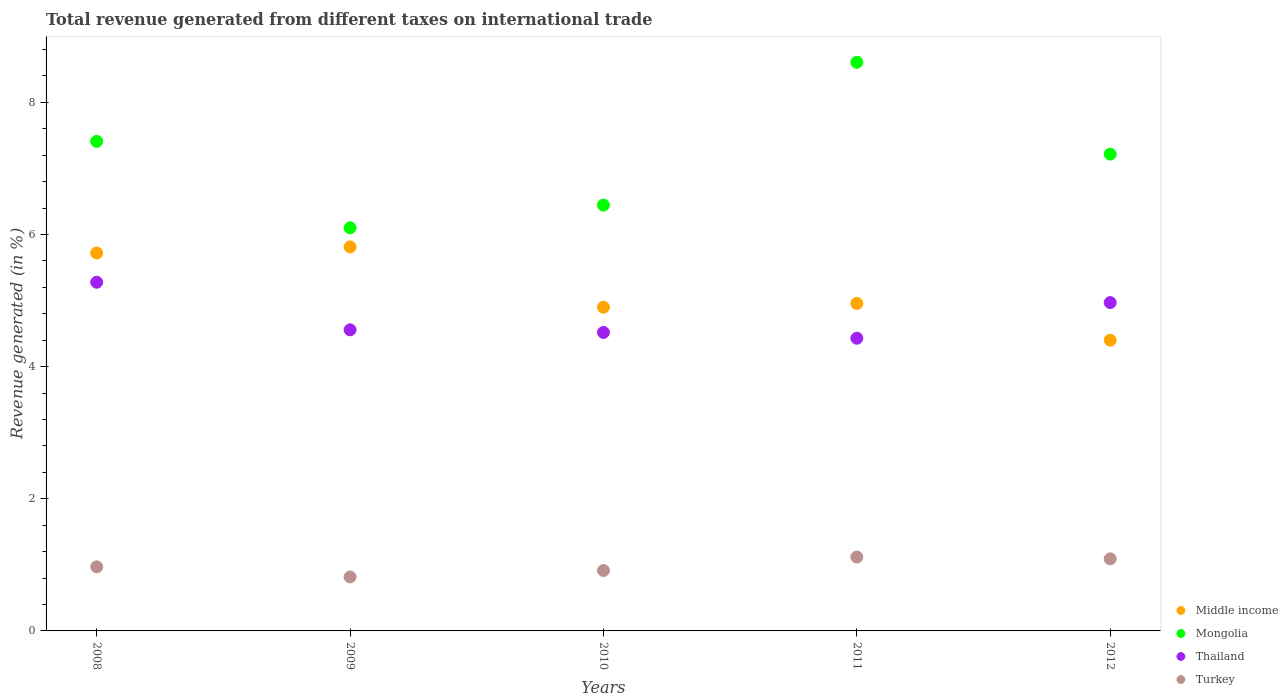What is the total revenue generated in Thailand in 2011?
Offer a terse response. 4.43. Across all years, what is the maximum total revenue generated in Mongolia?
Offer a very short reply. 8.61. Across all years, what is the minimum total revenue generated in Turkey?
Your answer should be compact. 0.82. What is the total total revenue generated in Turkey in the graph?
Give a very brief answer. 4.91. What is the difference between the total revenue generated in Turkey in 2008 and that in 2010?
Offer a very short reply. 0.06. What is the difference between the total revenue generated in Mongolia in 2011 and the total revenue generated in Thailand in 2010?
Offer a very short reply. 4.09. What is the average total revenue generated in Middle income per year?
Offer a very short reply. 5.16. In the year 2012, what is the difference between the total revenue generated in Turkey and total revenue generated in Thailand?
Make the answer very short. -3.88. In how many years, is the total revenue generated in Mongolia greater than 6.4 %?
Make the answer very short. 4. What is the ratio of the total revenue generated in Middle income in 2011 to that in 2012?
Offer a terse response. 1.13. Is the total revenue generated in Thailand in 2009 less than that in 2011?
Your answer should be very brief. No. What is the difference between the highest and the second highest total revenue generated in Thailand?
Make the answer very short. 0.31. What is the difference between the highest and the lowest total revenue generated in Mongolia?
Provide a succinct answer. 2.51. In how many years, is the total revenue generated in Middle income greater than the average total revenue generated in Middle income taken over all years?
Provide a succinct answer. 2. Is it the case that in every year, the sum of the total revenue generated in Thailand and total revenue generated in Turkey  is greater than the total revenue generated in Mongolia?
Keep it short and to the point. No. Does the total revenue generated in Thailand monotonically increase over the years?
Your response must be concise. No. Is the total revenue generated in Thailand strictly less than the total revenue generated in Middle income over the years?
Provide a succinct answer. No. How many dotlines are there?
Ensure brevity in your answer.  4. What is the difference between two consecutive major ticks on the Y-axis?
Make the answer very short. 2. Does the graph contain grids?
Your response must be concise. No. Where does the legend appear in the graph?
Offer a terse response. Bottom right. What is the title of the graph?
Keep it short and to the point. Total revenue generated from different taxes on international trade. Does "Latin America(developing only)" appear as one of the legend labels in the graph?
Offer a terse response. No. What is the label or title of the Y-axis?
Your response must be concise. Revenue generated (in %). What is the Revenue generated (in %) of Middle income in 2008?
Your answer should be very brief. 5.72. What is the Revenue generated (in %) in Mongolia in 2008?
Provide a succinct answer. 7.41. What is the Revenue generated (in %) of Thailand in 2008?
Your response must be concise. 5.28. What is the Revenue generated (in %) of Turkey in 2008?
Offer a very short reply. 0.97. What is the Revenue generated (in %) of Middle income in 2009?
Ensure brevity in your answer.  5.81. What is the Revenue generated (in %) in Mongolia in 2009?
Provide a succinct answer. 6.1. What is the Revenue generated (in %) in Thailand in 2009?
Offer a terse response. 4.56. What is the Revenue generated (in %) in Turkey in 2009?
Make the answer very short. 0.82. What is the Revenue generated (in %) in Middle income in 2010?
Make the answer very short. 4.9. What is the Revenue generated (in %) in Mongolia in 2010?
Offer a very short reply. 6.44. What is the Revenue generated (in %) in Thailand in 2010?
Offer a terse response. 4.52. What is the Revenue generated (in %) in Turkey in 2010?
Ensure brevity in your answer.  0.91. What is the Revenue generated (in %) in Middle income in 2011?
Your response must be concise. 4.96. What is the Revenue generated (in %) in Mongolia in 2011?
Give a very brief answer. 8.61. What is the Revenue generated (in %) in Thailand in 2011?
Your answer should be very brief. 4.43. What is the Revenue generated (in %) in Turkey in 2011?
Offer a very short reply. 1.12. What is the Revenue generated (in %) in Middle income in 2012?
Give a very brief answer. 4.4. What is the Revenue generated (in %) of Mongolia in 2012?
Provide a short and direct response. 7.22. What is the Revenue generated (in %) in Thailand in 2012?
Offer a very short reply. 4.97. What is the Revenue generated (in %) of Turkey in 2012?
Offer a very short reply. 1.09. Across all years, what is the maximum Revenue generated (in %) in Middle income?
Provide a succinct answer. 5.81. Across all years, what is the maximum Revenue generated (in %) of Mongolia?
Your answer should be very brief. 8.61. Across all years, what is the maximum Revenue generated (in %) in Thailand?
Your answer should be very brief. 5.28. Across all years, what is the maximum Revenue generated (in %) of Turkey?
Keep it short and to the point. 1.12. Across all years, what is the minimum Revenue generated (in %) in Middle income?
Keep it short and to the point. 4.4. Across all years, what is the minimum Revenue generated (in %) in Mongolia?
Provide a short and direct response. 6.1. Across all years, what is the minimum Revenue generated (in %) of Thailand?
Your answer should be very brief. 4.43. Across all years, what is the minimum Revenue generated (in %) of Turkey?
Make the answer very short. 0.82. What is the total Revenue generated (in %) in Middle income in the graph?
Ensure brevity in your answer.  25.79. What is the total Revenue generated (in %) in Mongolia in the graph?
Provide a short and direct response. 35.77. What is the total Revenue generated (in %) in Thailand in the graph?
Provide a short and direct response. 23.75. What is the total Revenue generated (in %) of Turkey in the graph?
Ensure brevity in your answer.  4.91. What is the difference between the Revenue generated (in %) of Middle income in 2008 and that in 2009?
Provide a succinct answer. -0.09. What is the difference between the Revenue generated (in %) in Mongolia in 2008 and that in 2009?
Your response must be concise. 1.31. What is the difference between the Revenue generated (in %) of Thailand in 2008 and that in 2009?
Offer a terse response. 0.72. What is the difference between the Revenue generated (in %) of Turkey in 2008 and that in 2009?
Provide a short and direct response. 0.15. What is the difference between the Revenue generated (in %) in Middle income in 2008 and that in 2010?
Ensure brevity in your answer.  0.82. What is the difference between the Revenue generated (in %) in Mongolia in 2008 and that in 2010?
Keep it short and to the point. 0.96. What is the difference between the Revenue generated (in %) in Thailand in 2008 and that in 2010?
Your answer should be very brief. 0.76. What is the difference between the Revenue generated (in %) of Turkey in 2008 and that in 2010?
Provide a short and direct response. 0.06. What is the difference between the Revenue generated (in %) of Middle income in 2008 and that in 2011?
Offer a terse response. 0.76. What is the difference between the Revenue generated (in %) in Mongolia in 2008 and that in 2011?
Ensure brevity in your answer.  -1.2. What is the difference between the Revenue generated (in %) of Thailand in 2008 and that in 2011?
Offer a very short reply. 0.85. What is the difference between the Revenue generated (in %) of Turkey in 2008 and that in 2011?
Keep it short and to the point. -0.15. What is the difference between the Revenue generated (in %) of Middle income in 2008 and that in 2012?
Give a very brief answer. 1.32. What is the difference between the Revenue generated (in %) of Mongolia in 2008 and that in 2012?
Offer a terse response. 0.19. What is the difference between the Revenue generated (in %) of Thailand in 2008 and that in 2012?
Provide a succinct answer. 0.31. What is the difference between the Revenue generated (in %) of Turkey in 2008 and that in 2012?
Give a very brief answer. -0.12. What is the difference between the Revenue generated (in %) of Middle income in 2009 and that in 2010?
Your answer should be compact. 0.91. What is the difference between the Revenue generated (in %) of Mongolia in 2009 and that in 2010?
Give a very brief answer. -0.34. What is the difference between the Revenue generated (in %) of Turkey in 2009 and that in 2010?
Your answer should be very brief. -0.1. What is the difference between the Revenue generated (in %) of Middle income in 2009 and that in 2011?
Ensure brevity in your answer.  0.85. What is the difference between the Revenue generated (in %) in Mongolia in 2009 and that in 2011?
Your answer should be very brief. -2.5. What is the difference between the Revenue generated (in %) of Thailand in 2009 and that in 2011?
Offer a very short reply. 0.13. What is the difference between the Revenue generated (in %) in Turkey in 2009 and that in 2011?
Offer a terse response. -0.3. What is the difference between the Revenue generated (in %) of Middle income in 2009 and that in 2012?
Give a very brief answer. 1.41. What is the difference between the Revenue generated (in %) in Mongolia in 2009 and that in 2012?
Provide a short and direct response. -1.12. What is the difference between the Revenue generated (in %) of Thailand in 2009 and that in 2012?
Your answer should be compact. -0.41. What is the difference between the Revenue generated (in %) in Turkey in 2009 and that in 2012?
Ensure brevity in your answer.  -0.27. What is the difference between the Revenue generated (in %) of Middle income in 2010 and that in 2011?
Provide a succinct answer. -0.06. What is the difference between the Revenue generated (in %) in Mongolia in 2010 and that in 2011?
Keep it short and to the point. -2.16. What is the difference between the Revenue generated (in %) in Thailand in 2010 and that in 2011?
Keep it short and to the point. 0.09. What is the difference between the Revenue generated (in %) of Turkey in 2010 and that in 2011?
Offer a terse response. -0.2. What is the difference between the Revenue generated (in %) of Middle income in 2010 and that in 2012?
Keep it short and to the point. 0.5. What is the difference between the Revenue generated (in %) in Mongolia in 2010 and that in 2012?
Provide a short and direct response. -0.77. What is the difference between the Revenue generated (in %) of Thailand in 2010 and that in 2012?
Your response must be concise. -0.45. What is the difference between the Revenue generated (in %) of Turkey in 2010 and that in 2012?
Give a very brief answer. -0.18. What is the difference between the Revenue generated (in %) in Middle income in 2011 and that in 2012?
Keep it short and to the point. 0.56. What is the difference between the Revenue generated (in %) of Mongolia in 2011 and that in 2012?
Give a very brief answer. 1.39. What is the difference between the Revenue generated (in %) of Thailand in 2011 and that in 2012?
Make the answer very short. -0.54. What is the difference between the Revenue generated (in %) in Turkey in 2011 and that in 2012?
Your answer should be compact. 0.03. What is the difference between the Revenue generated (in %) in Middle income in 2008 and the Revenue generated (in %) in Mongolia in 2009?
Your response must be concise. -0.38. What is the difference between the Revenue generated (in %) of Middle income in 2008 and the Revenue generated (in %) of Thailand in 2009?
Your answer should be very brief. 1.16. What is the difference between the Revenue generated (in %) of Middle income in 2008 and the Revenue generated (in %) of Turkey in 2009?
Provide a short and direct response. 4.9. What is the difference between the Revenue generated (in %) of Mongolia in 2008 and the Revenue generated (in %) of Thailand in 2009?
Offer a terse response. 2.85. What is the difference between the Revenue generated (in %) in Mongolia in 2008 and the Revenue generated (in %) in Turkey in 2009?
Provide a succinct answer. 6.59. What is the difference between the Revenue generated (in %) in Thailand in 2008 and the Revenue generated (in %) in Turkey in 2009?
Give a very brief answer. 4.46. What is the difference between the Revenue generated (in %) in Middle income in 2008 and the Revenue generated (in %) in Mongolia in 2010?
Give a very brief answer. -0.72. What is the difference between the Revenue generated (in %) in Middle income in 2008 and the Revenue generated (in %) in Thailand in 2010?
Your answer should be compact. 1.2. What is the difference between the Revenue generated (in %) of Middle income in 2008 and the Revenue generated (in %) of Turkey in 2010?
Your answer should be compact. 4.81. What is the difference between the Revenue generated (in %) of Mongolia in 2008 and the Revenue generated (in %) of Thailand in 2010?
Ensure brevity in your answer.  2.89. What is the difference between the Revenue generated (in %) in Mongolia in 2008 and the Revenue generated (in %) in Turkey in 2010?
Give a very brief answer. 6.49. What is the difference between the Revenue generated (in %) in Thailand in 2008 and the Revenue generated (in %) in Turkey in 2010?
Keep it short and to the point. 4.36. What is the difference between the Revenue generated (in %) of Middle income in 2008 and the Revenue generated (in %) of Mongolia in 2011?
Offer a very short reply. -2.89. What is the difference between the Revenue generated (in %) of Middle income in 2008 and the Revenue generated (in %) of Thailand in 2011?
Keep it short and to the point. 1.29. What is the difference between the Revenue generated (in %) in Middle income in 2008 and the Revenue generated (in %) in Turkey in 2011?
Your response must be concise. 4.6. What is the difference between the Revenue generated (in %) of Mongolia in 2008 and the Revenue generated (in %) of Thailand in 2011?
Provide a succinct answer. 2.98. What is the difference between the Revenue generated (in %) in Mongolia in 2008 and the Revenue generated (in %) in Turkey in 2011?
Your response must be concise. 6.29. What is the difference between the Revenue generated (in %) in Thailand in 2008 and the Revenue generated (in %) in Turkey in 2011?
Your response must be concise. 4.16. What is the difference between the Revenue generated (in %) in Middle income in 2008 and the Revenue generated (in %) in Mongolia in 2012?
Offer a terse response. -1.5. What is the difference between the Revenue generated (in %) in Middle income in 2008 and the Revenue generated (in %) in Thailand in 2012?
Give a very brief answer. 0.75. What is the difference between the Revenue generated (in %) of Middle income in 2008 and the Revenue generated (in %) of Turkey in 2012?
Your answer should be compact. 4.63. What is the difference between the Revenue generated (in %) of Mongolia in 2008 and the Revenue generated (in %) of Thailand in 2012?
Your response must be concise. 2.44. What is the difference between the Revenue generated (in %) of Mongolia in 2008 and the Revenue generated (in %) of Turkey in 2012?
Provide a succinct answer. 6.32. What is the difference between the Revenue generated (in %) of Thailand in 2008 and the Revenue generated (in %) of Turkey in 2012?
Your response must be concise. 4.19. What is the difference between the Revenue generated (in %) of Middle income in 2009 and the Revenue generated (in %) of Mongolia in 2010?
Your response must be concise. -0.63. What is the difference between the Revenue generated (in %) of Middle income in 2009 and the Revenue generated (in %) of Thailand in 2010?
Offer a very short reply. 1.29. What is the difference between the Revenue generated (in %) of Middle income in 2009 and the Revenue generated (in %) of Turkey in 2010?
Provide a short and direct response. 4.9. What is the difference between the Revenue generated (in %) in Mongolia in 2009 and the Revenue generated (in %) in Thailand in 2010?
Your response must be concise. 1.58. What is the difference between the Revenue generated (in %) in Mongolia in 2009 and the Revenue generated (in %) in Turkey in 2010?
Provide a short and direct response. 5.19. What is the difference between the Revenue generated (in %) of Thailand in 2009 and the Revenue generated (in %) of Turkey in 2010?
Provide a short and direct response. 3.64. What is the difference between the Revenue generated (in %) of Middle income in 2009 and the Revenue generated (in %) of Mongolia in 2011?
Provide a succinct answer. -2.79. What is the difference between the Revenue generated (in %) in Middle income in 2009 and the Revenue generated (in %) in Thailand in 2011?
Keep it short and to the point. 1.38. What is the difference between the Revenue generated (in %) of Middle income in 2009 and the Revenue generated (in %) of Turkey in 2011?
Provide a short and direct response. 4.69. What is the difference between the Revenue generated (in %) in Mongolia in 2009 and the Revenue generated (in %) in Thailand in 2011?
Give a very brief answer. 1.67. What is the difference between the Revenue generated (in %) of Mongolia in 2009 and the Revenue generated (in %) of Turkey in 2011?
Keep it short and to the point. 4.98. What is the difference between the Revenue generated (in %) in Thailand in 2009 and the Revenue generated (in %) in Turkey in 2011?
Make the answer very short. 3.44. What is the difference between the Revenue generated (in %) in Middle income in 2009 and the Revenue generated (in %) in Mongolia in 2012?
Offer a terse response. -1.4. What is the difference between the Revenue generated (in %) of Middle income in 2009 and the Revenue generated (in %) of Thailand in 2012?
Provide a succinct answer. 0.84. What is the difference between the Revenue generated (in %) of Middle income in 2009 and the Revenue generated (in %) of Turkey in 2012?
Offer a very short reply. 4.72. What is the difference between the Revenue generated (in %) of Mongolia in 2009 and the Revenue generated (in %) of Thailand in 2012?
Make the answer very short. 1.13. What is the difference between the Revenue generated (in %) in Mongolia in 2009 and the Revenue generated (in %) in Turkey in 2012?
Provide a succinct answer. 5.01. What is the difference between the Revenue generated (in %) in Thailand in 2009 and the Revenue generated (in %) in Turkey in 2012?
Provide a short and direct response. 3.47. What is the difference between the Revenue generated (in %) in Middle income in 2010 and the Revenue generated (in %) in Mongolia in 2011?
Your answer should be compact. -3.71. What is the difference between the Revenue generated (in %) in Middle income in 2010 and the Revenue generated (in %) in Thailand in 2011?
Your response must be concise. 0.47. What is the difference between the Revenue generated (in %) of Middle income in 2010 and the Revenue generated (in %) of Turkey in 2011?
Keep it short and to the point. 3.78. What is the difference between the Revenue generated (in %) in Mongolia in 2010 and the Revenue generated (in %) in Thailand in 2011?
Give a very brief answer. 2.01. What is the difference between the Revenue generated (in %) of Mongolia in 2010 and the Revenue generated (in %) of Turkey in 2011?
Your response must be concise. 5.33. What is the difference between the Revenue generated (in %) of Thailand in 2010 and the Revenue generated (in %) of Turkey in 2011?
Offer a very short reply. 3.4. What is the difference between the Revenue generated (in %) of Middle income in 2010 and the Revenue generated (in %) of Mongolia in 2012?
Your answer should be very brief. -2.32. What is the difference between the Revenue generated (in %) in Middle income in 2010 and the Revenue generated (in %) in Thailand in 2012?
Offer a terse response. -0.07. What is the difference between the Revenue generated (in %) of Middle income in 2010 and the Revenue generated (in %) of Turkey in 2012?
Your answer should be very brief. 3.81. What is the difference between the Revenue generated (in %) of Mongolia in 2010 and the Revenue generated (in %) of Thailand in 2012?
Your answer should be very brief. 1.47. What is the difference between the Revenue generated (in %) in Mongolia in 2010 and the Revenue generated (in %) in Turkey in 2012?
Ensure brevity in your answer.  5.35. What is the difference between the Revenue generated (in %) of Thailand in 2010 and the Revenue generated (in %) of Turkey in 2012?
Your response must be concise. 3.43. What is the difference between the Revenue generated (in %) in Middle income in 2011 and the Revenue generated (in %) in Mongolia in 2012?
Your answer should be very brief. -2.26. What is the difference between the Revenue generated (in %) of Middle income in 2011 and the Revenue generated (in %) of Thailand in 2012?
Provide a succinct answer. -0.01. What is the difference between the Revenue generated (in %) of Middle income in 2011 and the Revenue generated (in %) of Turkey in 2012?
Provide a succinct answer. 3.87. What is the difference between the Revenue generated (in %) in Mongolia in 2011 and the Revenue generated (in %) in Thailand in 2012?
Make the answer very short. 3.64. What is the difference between the Revenue generated (in %) of Mongolia in 2011 and the Revenue generated (in %) of Turkey in 2012?
Make the answer very short. 7.51. What is the difference between the Revenue generated (in %) in Thailand in 2011 and the Revenue generated (in %) in Turkey in 2012?
Your response must be concise. 3.34. What is the average Revenue generated (in %) in Middle income per year?
Your answer should be compact. 5.16. What is the average Revenue generated (in %) of Mongolia per year?
Provide a succinct answer. 7.15. What is the average Revenue generated (in %) of Thailand per year?
Provide a succinct answer. 4.75. What is the average Revenue generated (in %) in Turkey per year?
Provide a short and direct response. 0.98. In the year 2008, what is the difference between the Revenue generated (in %) of Middle income and Revenue generated (in %) of Mongolia?
Give a very brief answer. -1.69. In the year 2008, what is the difference between the Revenue generated (in %) in Middle income and Revenue generated (in %) in Thailand?
Give a very brief answer. 0.44. In the year 2008, what is the difference between the Revenue generated (in %) of Middle income and Revenue generated (in %) of Turkey?
Ensure brevity in your answer.  4.75. In the year 2008, what is the difference between the Revenue generated (in %) of Mongolia and Revenue generated (in %) of Thailand?
Offer a very short reply. 2.13. In the year 2008, what is the difference between the Revenue generated (in %) of Mongolia and Revenue generated (in %) of Turkey?
Ensure brevity in your answer.  6.44. In the year 2008, what is the difference between the Revenue generated (in %) of Thailand and Revenue generated (in %) of Turkey?
Keep it short and to the point. 4.31. In the year 2009, what is the difference between the Revenue generated (in %) in Middle income and Revenue generated (in %) in Mongolia?
Ensure brevity in your answer.  -0.29. In the year 2009, what is the difference between the Revenue generated (in %) in Middle income and Revenue generated (in %) in Thailand?
Provide a succinct answer. 1.25. In the year 2009, what is the difference between the Revenue generated (in %) in Middle income and Revenue generated (in %) in Turkey?
Give a very brief answer. 4.99. In the year 2009, what is the difference between the Revenue generated (in %) in Mongolia and Revenue generated (in %) in Thailand?
Provide a short and direct response. 1.54. In the year 2009, what is the difference between the Revenue generated (in %) in Mongolia and Revenue generated (in %) in Turkey?
Make the answer very short. 5.28. In the year 2009, what is the difference between the Revenue generated (in %) in Thailand and Revenue generated (in %) in Turkey?
Your answer should be compact. 3.74. In the year 2010, what is the difference between the Revenue generated (in %) of Middle income and Revenue generated (in %) of Mongolia?
Keep it short and to the point. -1.54. In the year 2010, what is the difference between the Revenue generated (in %) of Middle income and Revenue generated (in %) of Thailand?
Provide a succinct answer. 0.38. In the year 2010, what is the difference between the Revenue generated (in %) of Middle income and Revenue generated (in %) of Turkey?
Ensure brevity in your answer.  3.99. In the year 2010, what is the difference between the Revenue generated (in %) in Mongolia and Revenue generated (in %) in Thailand?
Provide a short and direct response. 1.93. In the year 2010, what is the difference between the Revenue generated (in %) of Mongolia and Revenue generated (in %) of Turkey?
Provide a succinct answer. 5.53. In the year 2010, what is the difference between the Revenue generated (in %) of Thailand and Revenue generated (in %) of Turkey?
Offer a terse response. 3.6. In the year 2011, what is the difference between the Revenue generated (in %) in Middle income and Revenue generated (in %) in Mongolia?
Your response must be concise. -3.65. In the year 2011, what is the difference between the Revenue generated (in %) in Middle income and Revenue generated (in %) in Thailand?
Offer a very short reply. 0.53. In the year 2011, what is the difference between the Revenue generated (in %) of Middle income and Revenue generated (in %) of Turkey?
Give a very brief answer. 3.84. In the year 2011, what is the difference between the Revenue generated (in %) in Mongolia and Revenue generated (in %) in Thailand?
Give a very brief answer. 4.18. In the year 2011, what is the difference between the Revenue generated (in %) of Mongolia and Revenue generated (in %) of Turkey?
Your response must be concise. 7.49. In the year 2011, what is the difference between the Revenue generated (in %) in Thailand and Revenue generated (in %) in Turkey?
Keep it short and to the point. 3.31. In the year 2012, what is the difference between the Revenue generated (in %) in Middle income and Revenue generated (in %) in Mongolia?
Provide a short and direct response. -2.82. In the year 2012, what is the difference between the Revenue generated (in %) in Middle income and Revenue generated (in %) in Thailand?
Provide a succinct answer. -0.57. In the year 2012, what is the difference between the Revenue generated (in %) of Middle income and Revenue generated (in %) of Turkey?
Provide a succinct answer. 3.31. In the year 2012, what is the difference between the Revenue generated (in %) of Mongolia and Revenue generated (in %) of Thailand?
Your answer should be very brief. 2.25. In the year 2012, what is the difference between the Revenue generated (in %) of Mongolia and Revenue generated (in %) of Turkey?
Your answer should be compact. 6.13. In the year 2012, what is the difference between the Revenue generated (in %) of Thailand and Revenue generated (in %) of Turkey?
Your answer should be very brief. 3.88. What is the ratio of the Revenue generated (in %) in Middle income in 2008 to that in 2009?
Offer a very short reply. 0.98. What is the ratio of the Revenue generated (in %) in Mongolia in 2008 to that in 2009?
Your response must be concise. 1.21. What is the ratio of the Revenue generated (in %) in Thailand in 2008 to that in 2009?
Your answer should be very brief. 1.16. What is the ratio of the Revenue generated (in %) of Turkey in 2008 to that in 2009?
Your answer should be very brief. 1.19. What is the ratio of the Revenue generated (in %) of Middle income in 2008 to that in 2010?
Give a very brief answer. 1.17. What is the ratio of the Revenue generated (in %) of Mongolia in 2008 to that in 2010?
Give a very brief answer. 1.15. What is the ratio of the Revenue generated (in %) in Thailand in 2008 to that in 2010?
Your response must be concise. 1.17. What is the ratio of the Revenue generated (in %) in Turkey in 2008 to that in 2010?
Provide a succinct answer. 1.06. What is the ratio of the Revenue generated (in %) of Middle income in 2008 to that in 2011?
Ensure brevity in your answer.  1.15. What is the ratio of the Revenue generated (in %) in Mongolia in 2008 to that in 2011?
Your answer should be very brief. 0.86. What is the ratio of the Revenue generated (in %) in Thailand in 2008 to that in 2011?
Your response must be concise. 1.19. What is the ratio of the Revenue generated (in %) in Turkey in 2008 to that in 2011?
Offer a terse response. 0.87. What is the ratio of the Revenue generated (in %) of Middle income in 2008 to that in 2012?
Keep it short and to the point. 1.3. What is the ratio of the Revenue generated (in %) of Mongolia in 2008 to that in 2012?
Ensure brevity in your answer.  1.03. What is the ratio of the Revenue generated (in %) of Thailand in 2008 to that in 2012?
Your response must be concise. 1.06. What is the ratio of the Revenue generated (in %) of Middle income in 2009 to that in 2010?
Offer a very short reply. 1.19. What is the ratio of the Revenue generated (in %) in Mongolia in 2009 to that in 2010?
Offer a terse response. 0.95. What is the ratio of the Revenue generated (in %) in Thailand in 2009 to that in 2010?
Provide a short and direct response. 1.01. What is the ratio of the Revenue generated (in %) in Turkey in 2009 to that in 2010?
Your answer should be very brief. 0.89. What is the ratio of the Revenue generated (in %) of Middle income in 2009 to that in 2011?
Your answer should be compact. 1.17. What is the ratio of the Revenue generated (in %) in Mongolia in 2009 to that in 2011?
Your answer should be compact. 0.71. What is the ratio of the Revenue generated (in %) of Thailand in 2009 to that in 2011?
Give a very brief answer. 1.03. What is the ratio of the Revenue generated (in %) of Turkey in 2009 to that in 2011?
Make the answer very short. 0.73. What is the ratio of the Revenue generated (in %) of Middle income in 2009 to that in 2012?
Give a very brief answer. 1.32. What is the ratio of the Revenue generated (in %) of Mongolia in 2009 to that in 2012?
Provide a short and direct response. 0.85. What is the ratio of the Revenue generated (in %) of Thailand in 2009 to that in 2012?
Offer a terse response. 0.92. What is the ratio of the Revenue generated (in %) in Turkey in 2009 to that in 2012?
Your response must be concise. 0.75. What is the ratio of the Revenue generated (in %) of Middle income in 2010 to that in 2011?
Keep it short and to the point. 0.99. What is the ratio of the Revenue generated (in %) in Mongolia in 2010 to that in 2011?
Give a very brief answer. 0.75. What is the ratio of the Revenue generated (in %) of Thailand in 2010 to that in 2011?
Keep it short and to the point. 1.02. What is the ratio of the Revenue generated (in %) of Turkey in 2010 to that in 2011?
Make the answer very short. 0.82. What is the ratio of the Revenue generated (in %) in Middle income in 2010 to that in 2012?
Make the answer very short. 1.11. What is the ratio of the Revenue generated (in %) of Mongolia in 2010 to that in 2012?
Provide a succinct answer. 0.89. What is the ratio of the Revenue generated (in %) of Thailand in 2010 to that in 2012?
Your answer should be compact. 0.91. What is the ratio of the Revenue generated (in %) of Turkey in 2010 to that in 2012?
Offer a terse response. 0.84. What is the ratio of the Revenue generated (in %) in Middle income in 2011 to that in 2012?
Make the answer very short. 1.13. What is the ratio of the Revenue generated (in %) of Mongolia in 2011 to that in 2012?
Your response must be concise. 1.19. What is the ratio of the Revenue generated (in %) in Thailand in 2011 to that in 2012?
Your answer should be compact. 0.89. What is the ratio of the Revenue generated (in %) of Turkey in 2011 to that in 2012?
Offer a very short reply. 1.02. What is the difference between the highest and the second highest Revenue generated (in %) in Middle income?
Your response must be concise. 0.09. What is the difference between the highest and the second highest Revenue generated (in %) in Mongolia?
Offer a terse response. 1.2. What is the difference between the highest and the second highest Revenue generated (in %) of Thailand?
Provide a succinct answer. 0.31. What is the difference between the highest and the second highest Revenue generated (in %) of Turkey?
Provide a short and direct response. 0.03. What is the difference between the highest and the lowest Revenue generated (in %) of Middle income?
Offer a very short reply. 1.41. What is the difference between the highest and the lowest Revenue generated (in %) of Mongolia?
Ensure brevity in your answer.  2.5. What is the difference between the highest and the lowest Revenue generated (in %) in Thailand?
Give a very brief answer. 0.85. What is the difference between the highest and the lowest Revenue generated (in %) of Turkey?
Your response must be concise. 0.3. 